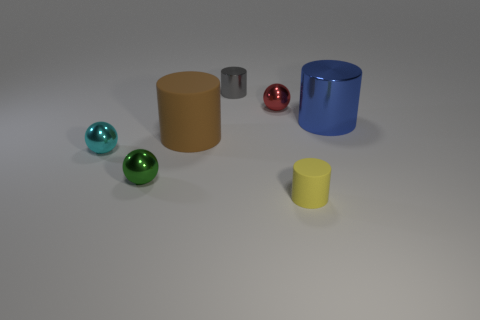Are there any large brown objects that have the same shape as the blue object?
Offer a very short reply. Yes. What is the material of the large thing on the left side of the yellow cylinder?
Make the answer very short. Rubber. Is the red shiny thing the same shape as the tiny cyan metal object?
Keep it short and to the point. Yes. What is the color of the big metallic object that is the same shape as the large brown matte object?
Your answer should be compact. Blue. Are there more large blue cylinders that are in front of the red metallic ball than brown matte cubes?
Your answer should be very brief. Yes. What color is the matte cylinder to the left of the gray metallic cylinder?
Your response must be concise. Brown. Is the size of the blue shiny object the same as the brown matte cylinder?
Your answer should be compact. Yes. The cyan metal object has what size?
Your answer should be very brief. Small. Are there more red rubber cylinders than tiny metal cylinders?
Offer a very short reply. No. The big object that is in front of the object to the right of the small cylinder that is in front of the red metal sphere is what color?
Ensure brevity in your answer.  Brown. 